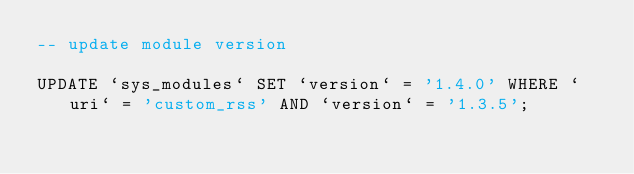<code> <loc_0><loc_0><loc_500><loc_500><_SQL_>-- update module version

UPDATE `sys_modules` SET `version` = '1.4.0' WHERE `uri` = 'custom_rss' AND `version` = '1.3.5';

</code> 